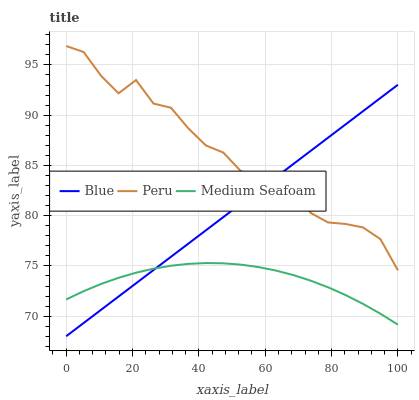Does Medium Seafoam have the minimum area under the curve?
Answer yes or no. Yes. Does Peru have the maximum area under the curve?
Answer yes or no. Yes. Does Peru have the minimum area under the curve?
Answer yes or no. No. Does Medium Seafoam have the maximum area under the curve?
Answer yes or no. No. Is Blue the smoothest?
Answer yes or no. Yes. Is Peru the roughest?
Answer yes or no. Yes. Is Medium Seafoam the smoothest?
Answer yes or no. No. Is Medium Seafoam the roughest?
Answer yes or no. No. Does Medium Seafoam have the lowest value?
Answer yes or no. No. Does Peru have the highest value?
Answer yes or no. Yes. Does Medium Seafoam have the highest value?
Answer yes or no. No. Is Medium Seafoam less than Peru?
Answer yes or no. Yes. Is Peru greater than Medium Seafoam?
Answer yes or no. Yes. Does Medium Seafoam intersect Blue?
Answer yes or no. Yes. Is Medium Seafoam less than Blue?
Answer yes or no. No. Is Medium Seafoam greater than Blue?
Answer yes or no. No. Does Medium Seafoam intersect Peru?
Answer yes or no. No. 